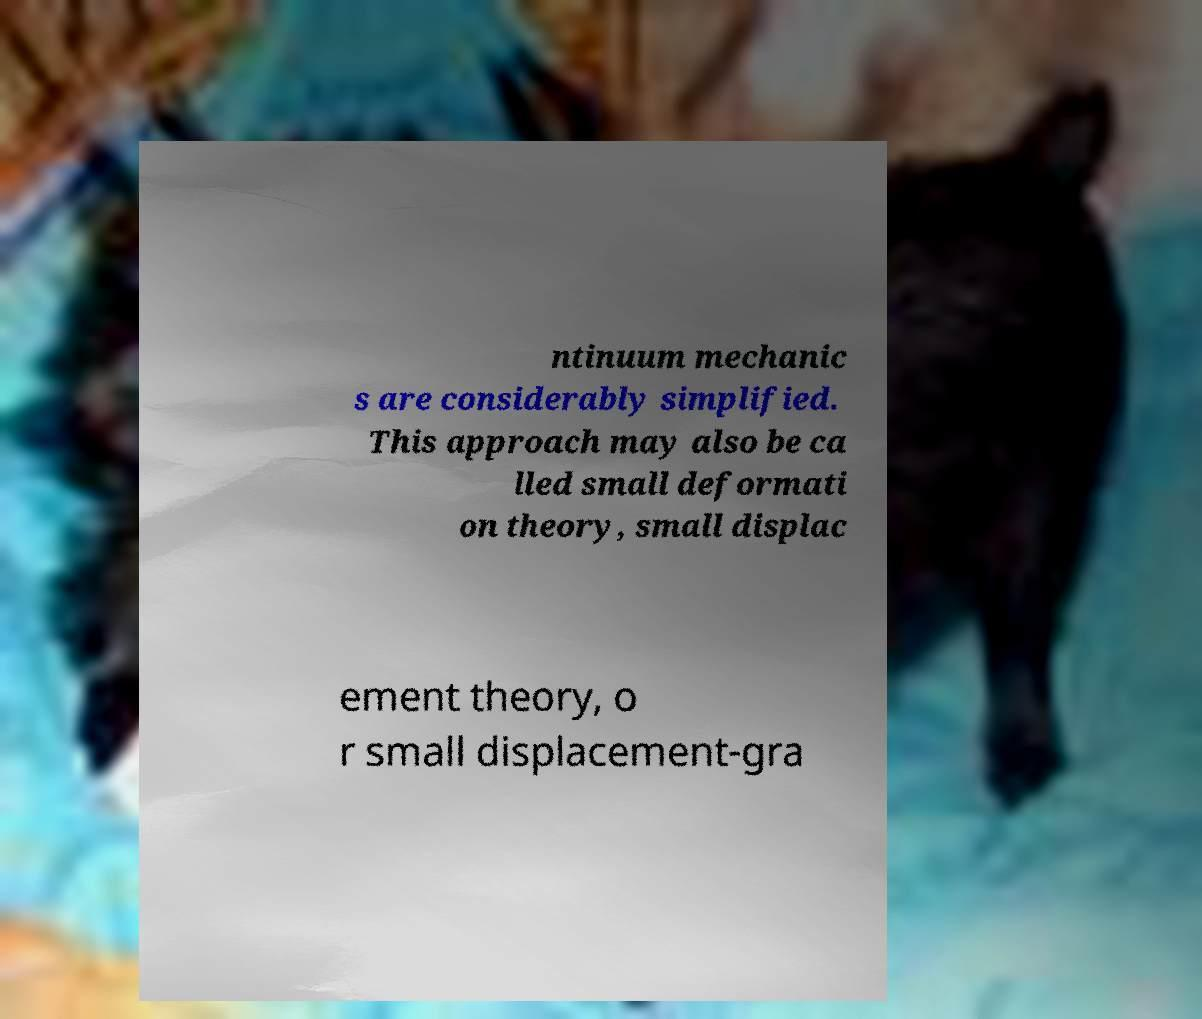Please read and relay the text visible in this image. What does it say? ntinuum mechanic s are considerably simplified. This approach may also be ca lled small deformati on theory, small displac ement theory, o r small displacement-gra 